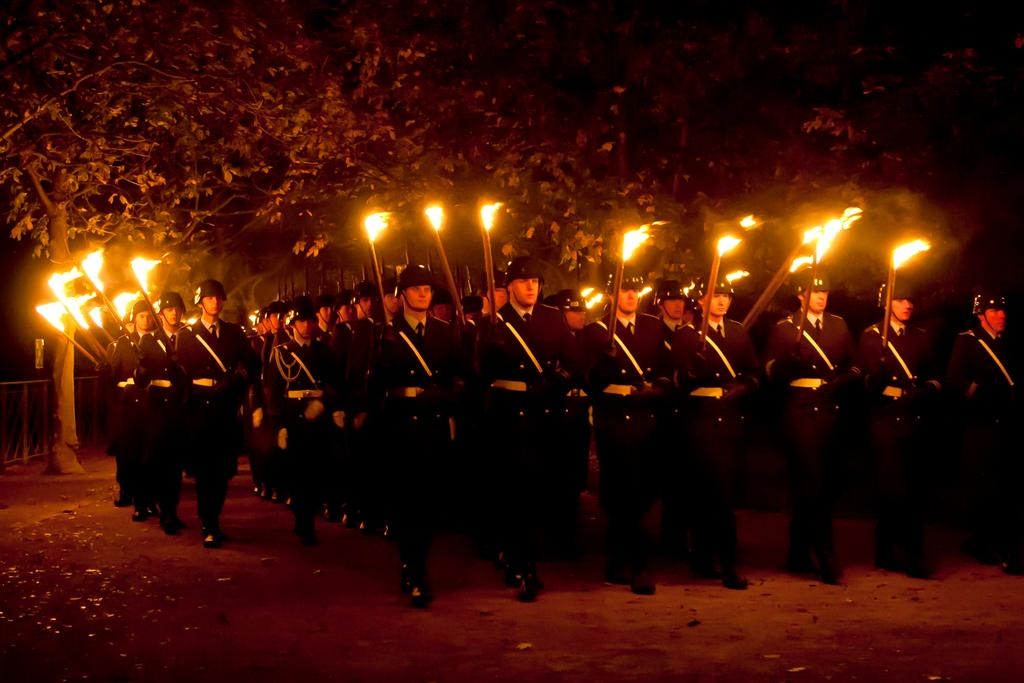What is the main subject in the foreground of the image? There is a crowd of men in the foreground of the image. What are the men holding in their hands? The men are holding fire sticks in their hands. What are the men doing with the fire sticks? The men are standing and holding fire sticks in their hands. What can be seen in the background of the image? There are trees in the background of the image. How many spoons are visible in the image? There are no spoons visible in the image. What type of clover can be seen growing near the trees in the background? There is no clover present in the image; only trees are visible in the background. 